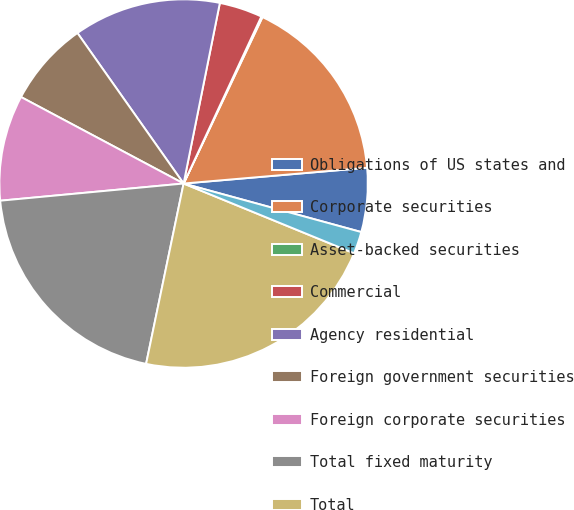Convert chart to OTSL. <chart><loc_0><loc_0><loc_500><loc_500><pie_chart><fcel>Obligations of US states and<fcel>Corporate securities<fcel>Asset-backed securities<fcel>Commercial<fcel>Agency residential<fcel>Foreign government securities<fcel>Foreign corporate securities<fcel>Total fixed maturity<fcel>Total<fcel>Due in one year or less<nl><fcel>5.61%<fcel>16.59%<fcel>0.11%<fcel>3.78%<fcel>12.93%<fcel>7.44%<fcel>9.27%<fcel>20.25%<fcel>22.08%<fcel>1.94%<nl></chart> 